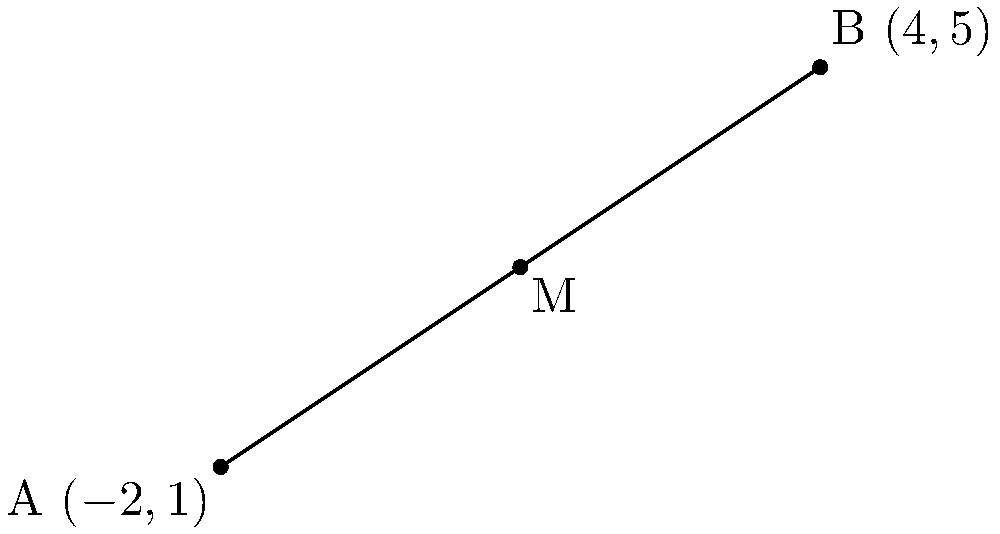In the coordinate plane above, points A and B are given with coordinates A(-2,1) and B(4,5). Find the coordinates of the midpoint M of line segment AB using the midpoint formula. To find the midpoint of a line segment using coordinate geometry, we can follow these steps:

1. Recall the midpoint formula: The midpoint M(x,y) of a line segment with endpoints (x₁,y₁) and (x₂,y₂) is given by:

   $$ M\left(\frac{x_1 + x_2}{2}, \frac{y_1 + y_2}{2}\right) $$

2. Identify the coordinates:
   A(-2,1): x₁ = -2, y₁ = 1
   B(4,5):  x₂ = 4,  y₂ = 5

3. Apply the midpoint formula:

   x-coordinate of M: $\frac{x_1 + x_2}{2} = \frac{-2 + 4}{2} = \frac{2}{2} = 1$

   y-coordinate of M: $\frac{y_1 + y_2}{2} = \frac{1 + 5}{2} = \frac{6}{2} = 3$

4. Combine the results to get the coordinates of the midpoint M(1,3).
Answer: M(1,3) 